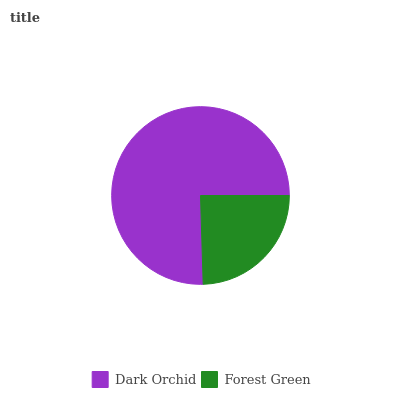Is Forest Green the minimum?
Answer yes or no. Yes. Is Dark Orchid the maximum?
Answer yes or no. Yes. Is Forest Green the maximum?
Answer yes or no. No. Is Dark Orchid greater than Forest Green?
Answer yes or no. Yes. Is Forest Green less than Dark Orchid?
Answer yes or no. Yes. Is Forest Green greater than Dark Orchid?
Answer yes or no. No. Is Dark Orchid less than Forest Green?
Answer yes or no. No. Is Dark Orchid the high median?
Answer yes or no. Yes. Is Forest Green the low median?
Answer yes or no. Yes. Is Forest Green the high median?
Answer yes or no. No. Is Dark Orchid the low median?
Answer yes or no. No. 